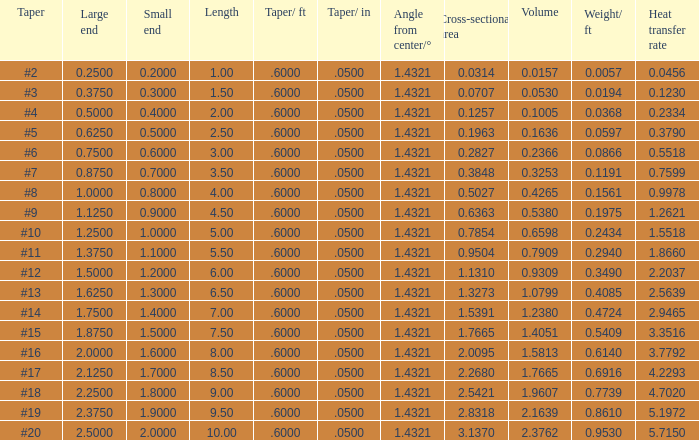Which Angle from center/° has a Taper/ft smaller than 0.6000000000000001? 19.0. Give me the full table as a dictionary. {'header': ['Taper', 'Large end', 'Small end', 'Length', 'Taper/ ft', 'Taper/ in', 'Angle from center/°', 'Cross-sectional area', 'Volume', 'Weight/ ft', 'Heat transfer rate'], 'rows': [['#2', '0.2500', '0.2000', '1.00', '.6000', '.0500', '1.4321', '0.0314', '0.0157', '0.0057', '0.0456'], ['#3', '0.3750', '0.3000', '1.50', '.6000', '.0500', '1.4321', '0.0707', '0.0530', '0.0194', '0.1230'], ['#4', '0.5000', '0.4000', '2.00', '.6000', '.0500', '1.4321', '0.1257', '0.1005', '0.0368', '0.2334'], ['#5', '0.6250', '0.5000', '2.50', '.6000', '.0500', '1.4321', '0.1963', '0.1636', '0.0597', '0.3790'], ['#6', '0.7500', '0.6000', '3.00', '.6000', '.0500', '1.4321', '0.2827', '0.2366', '0.0866', '0.5518'], ['#7', '0.8750', '0.7000', '3.50', '.6000', '.0500', '1.4321', '0.3848', '0.3253', '0.1191', '0.7599'], ['#8', '1.0000', '0.8000', '4.00', '.6000', '.0500', '1.4321', '0.5027', '0.4265', '0.1561', '0.9978'], ['#9', '1.1250', '0.9000', '4.50', '.6000', '.0500', '1.4321', '0.6363', '0.5380', '0.1975', '1.2621'], ['#10', '1.2500', '1.0000', '5.00', '.6000', '.0500', '1.4321', '0.7854', '0.6598', '0.2434', '1.5518'], ['#11', '1.3750', '1.1000', '5.50', '.6000', '.0500', '1.4321', '0.9504', '0.7909', '0.2940', '1.8660'], ['#12', '1.5000', '1.2000', '6.00', '.6000', '.0500', '1.4321', '1.1310', '0.9309', '0.3490', '2.2037'], ['#13', '1.6250', '1.3000', '6.50', '.6000', '.0500', '1.4321', '1.3273', '1.0799', '0.4085', '2.5639'], ['#14', '1.7500', '1.4000', '7.00', '.6000', '.0500', '1.4321', '1.5391', '1.2380', '0.4724', '2.9465'], ['#15', '1.8750', '1.5000', '7.50', '.6000', '.0500', '1.4321', '1.7665', '1.4051', '0.5409', '3.3516'], ['#16', '2.0000', '1.6000', '8.00', '.6000', '.0500', '1.4321', '2.0095', '1.5813', '0.6140', '3.7792'], ['#17', '2.1250', '1.7000', '8.50', '.6000', '.0500', '1.4321', '2.2680', '1.7665', '0.6916', '4.2293'], ['#18', '2.2500', '1.8000', '9.00', '.6000', '.0500', '1.4321', '2.5421', '1.9607', '0.7739', '4.7020'], ['#19', '2.3750', '1.9000', '9.50', '.6000', '.0500', '1.4321', '2.8318', '2.1639', '0.8610', '5.1972'], ['#20', '2.5000', '2.0000', '10.00', '.6000', '.0500', '1.4321', '3.1370', '2.3762', '0.9530', '5.7150']]} 